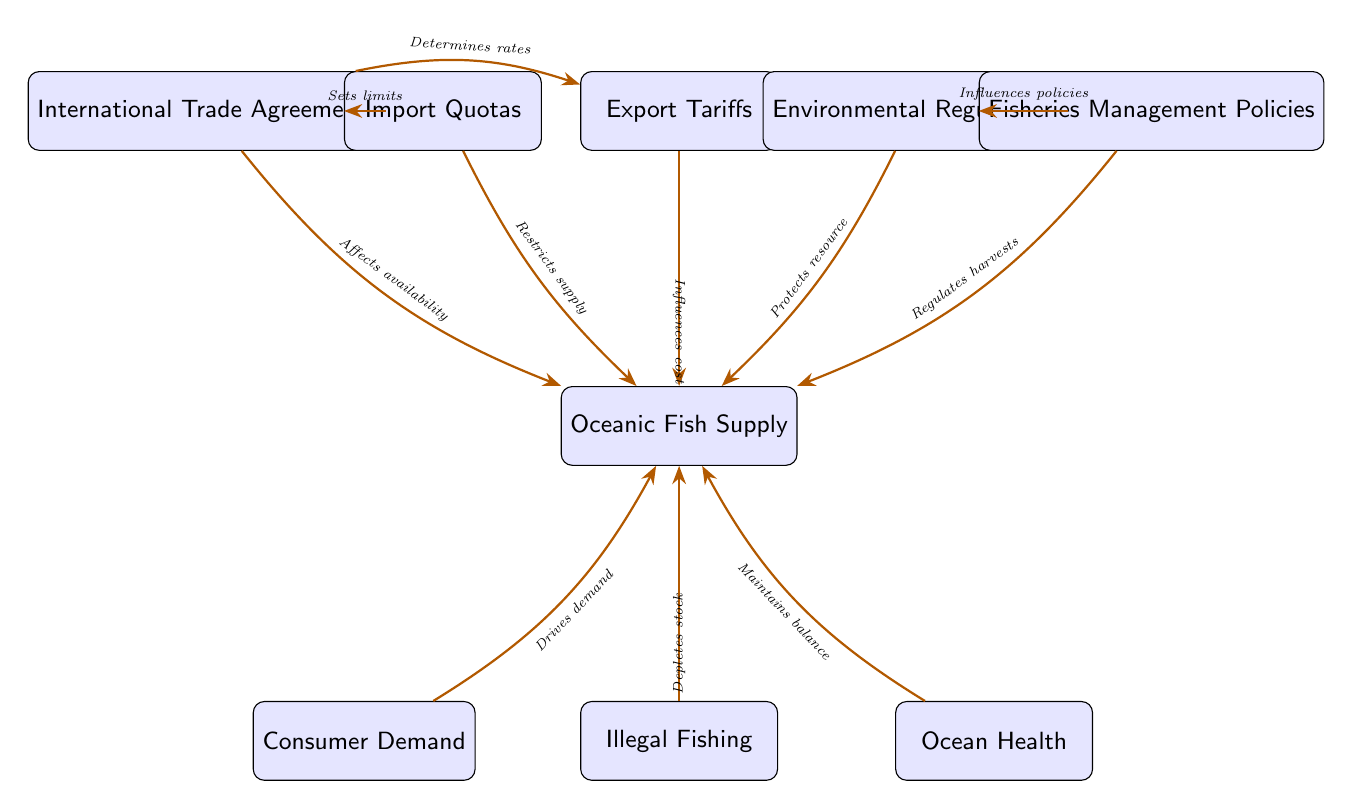What is the starting node of the flow? The diagram's flow begins with the node labeled "Oceanic Fish Supply," which is positioned at the center. This is the initial point from which all other relationships and influences extend outward.
Answer: Oceanic Fish Supply How many nodes are in the diagram? Counting the total number of distinct elements in the diagram, including the main node and all influences, we find there are 9 nodes in total.
Answer: 9 What does "Import Quotas" do to "Oceanic Fish Supply"? The arrow from "Import Quotas" points to "Oceanic Fish Supply" and is labeled "Restricts supply," indicating that import quotas limit the amount of fish that can be supplied.
Answer: Restricts supply Which node influences "Fisheries Management Policies"? "Environmental Regulations" directly points to "Fisheries Management Policies," showing that these regulations can shape or influence how fisheries are managed.
Answer: Environmental Regulations What relationship exists between "Consumer Demand" and "Oceanic Fish Supply"? The connection indicates that "Consumer Demand" drives demand for "Oceanic Fish Supply," signifying that demand levels can affect the overall supply of oceanic fish.
Answer: Drives demand What is the impact of "Illegal Fishing" on "Oceanic Fish Supply"? The link between "Illegal Fishing" and "Oceanic Fish Supply" is indicated as "Depletes stock," suggesting that illegal fishing activities reduce the availability of fish.
Answer: Depletes stock How do "International Trade Agreements" affect "Import Quotas"? The arrow shows that "International Trade Agreements" set limits on "Import Quotas," establishing the rules that define how much can be imported based on these agreements.
Answer: Sets limits What is the role of "Export Tariffs" concerning "Oceanic Fish Supply"? "Export Tariffs" are shown to influence the cost of "Oceanic Fish Supply," impacting the overall pricing and market dynamics for exported fish.
Answer: Influences cost What two factors influence "Fisheries Management Policies"? The diagram indicates that "Environmental Regulations" and "International Trade Agreements" both influence "Fisheries Management Policies," highlighting their role in resource management strategies.
Answer: Environmental Regulations, International Trade Agreements 